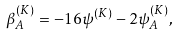Convert formula to latex. <formula><loc_0><loc_0><loc_500><loc_500>\beta ^ { ( K ) } _ { A } = - 1 6 \psi ^ { ( K ) } - 2 \psi ^ { ( K ) } _ { A } ,</formula> 